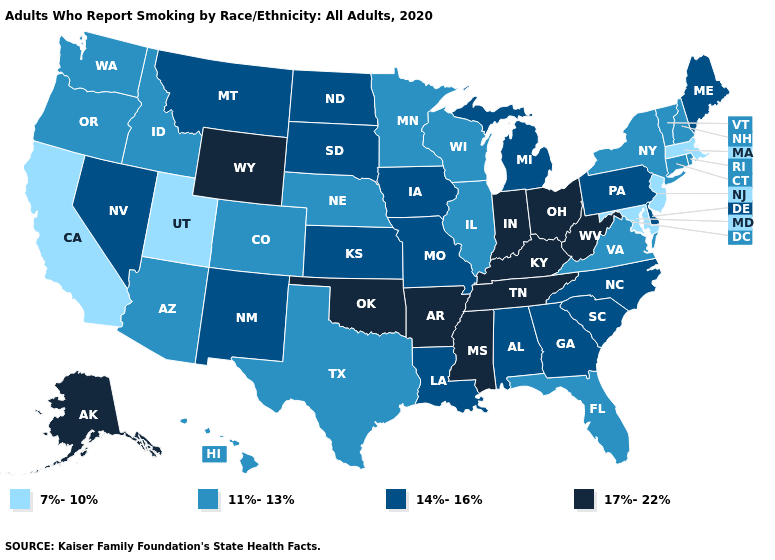What is the value of Kansas?
Be succinct. 14%-16%. Name the states that have a value in the range 11%-13%?
Quick response, please. Arizona, Colorado, Connecticut, Florida, Hawaii, Idaho, Illinois, Minnesota, Nebraska, New Hampshire, New York, Oregon, Rhode Island, Texas, Vermont, Virginia, Washington, Wisconsin. Does Kentucky have a higher value than West Virginia?
Keep it brief. No. What is the highest value in the Northeast ?
Be succinct. 14%-16%. What is the lowest value in states that border Nevada?
Keep it brief. 7%-10%. What is the highest value in states that border New York?
Short answer required. 14%-16%. What is the value of Virginia?
Short answer required. 11%-13%. Name the states that have a value in the range 14%-16%?
Keep it brief. Alabama, Delaware, Georgia, Iowa, Kansas, Louisiana, Maine, Michigan, Missouri, Montana, Nevada, New Mexico, North Carolina, North Dakota, Pennsylvania, South Carolina, South Dakota. Which states have the lowest value in the MidWest?
Answer briefly. Illinois, Minnesota, Nebraska, Wisconsin. Does Rhode Island have a higher value than Massachusetts?
Answer briefly. Yes. Does Oklahoma have a higher value than Kentucky?
Write a very short answer. No. Name the states that have a value in the range 7%-10%?
Give a very brief answer. California, Maryland, Massachusetts, New Jersey, Utah. Which states have the lowest value in the USA?
Concise answer only. California, Maryland, Massachusetts, New Jersey, Utah. Does Utah have the lowest value in the USA?
Give a very brief answer. Yes. 